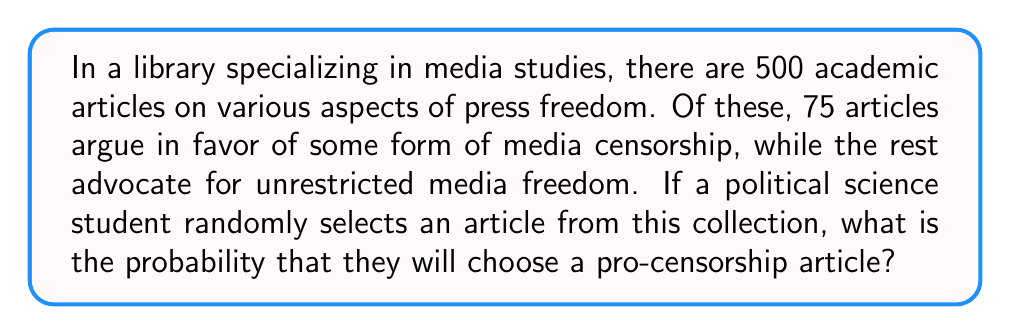Could you help me with this problem? To solve this problem, we need to use the concept of probability. The probability of an event is calculated by dividing the number of favorable outcomes by the total number of possible outcomes.

Let's define our variables:
$n$ = total number of articles = 500
$k$ = number of pro-censorship articles = 75

The probability of selecting a pro-censorship article is:

$$P(\text{pro-censorship}) = \frac{\text{number of pro-censorship articles}}{\text{total number of articles}}$$

$$P(\text{pro-censorship}) = \frac{k}{n} = \frac{75}{500}$$

To simplify this fraction, we can divide both the numerator and denominator by their greatest common divisor (GCD). The GCD of 75 and 500 is 25.

$$P(\text{pro-censorship}) = \frac{75 \div 25}{500 \div 25} = \frac{3}{20} = 0.15$$

We can also express this as a percentage:

$$P(\text{pro-censorship}) = 0.15 \times 100\% = 15\%$$

This means that there is a 15% chance of randomly selecting a pro-censorship article from the collection.
Answer: $\frac{3}{20}$ or $0.15$ or $15\%$ 